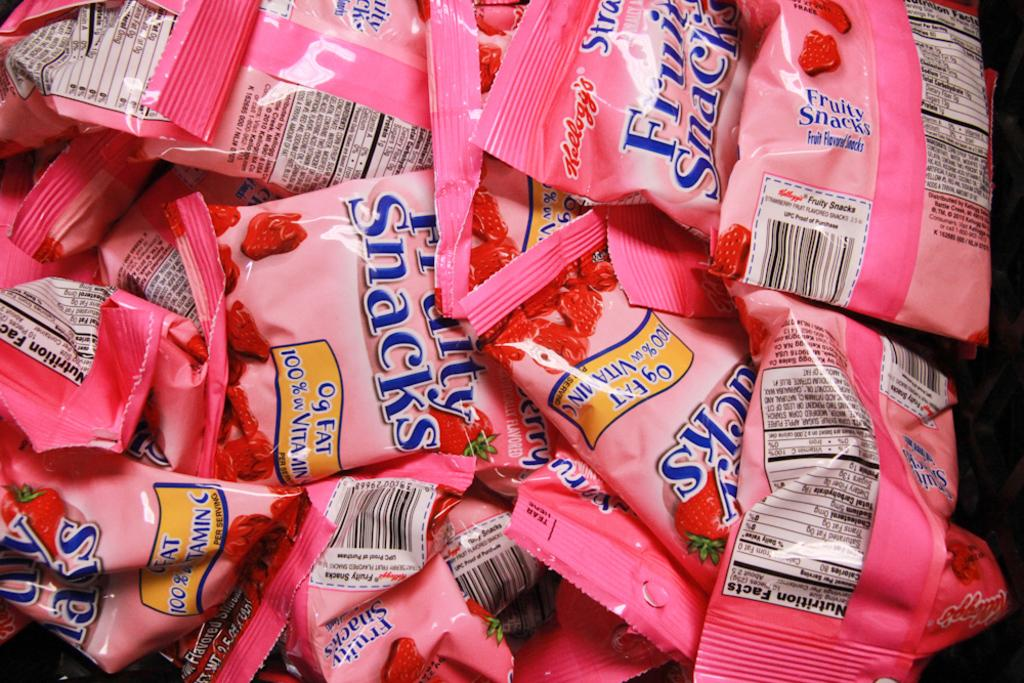What objects are present in the image? There are packets in the image. What can be seen on the surface of the packets? The packets have printed text on them. What type of drug is being distributed in the image? There is no indication of any drug in the image; it only shows packets with printed text on them. 